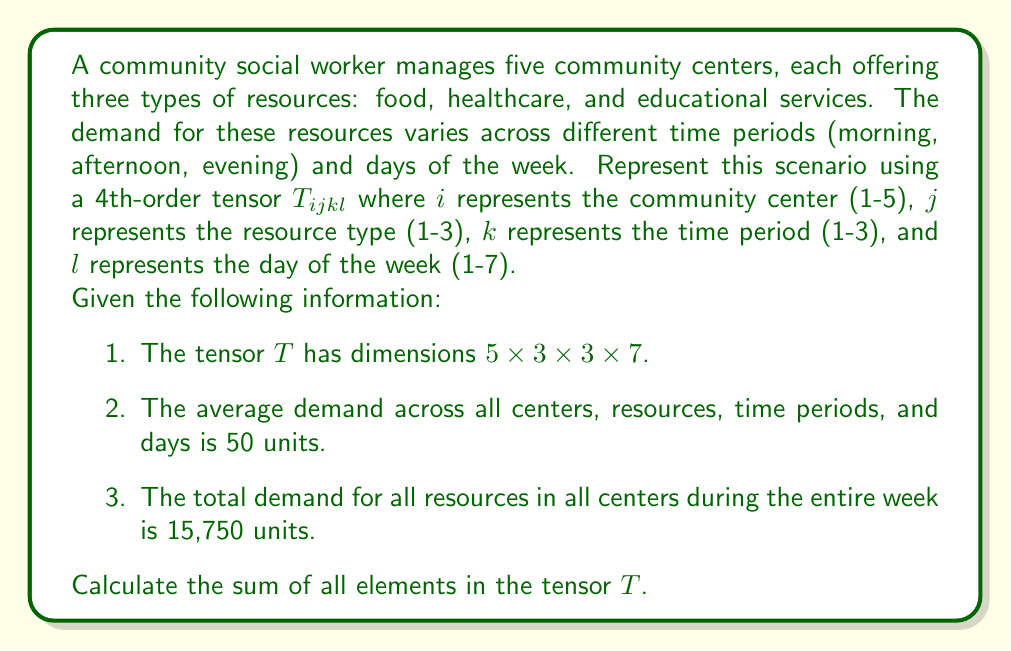Could you help me with this problem? To solve this problem, we'll follow these steps:

1) First, let's understand what the tensor $T_{ijkl}$ represents:
   - $i$ ranges from 1 to 5 (community centers)
   - $j$ ranges from 1 to 3 (resource types)
   - $k$ ranges from 1 to 3 (time periods)
   - $l$ ranges from 1 to 7 (days of the week)

2) The total number of elements in the tensor is:
   $$ 5 \times 3 \times 3 \times 7 = 315 $$

3) We're given that the average demand across all elements is 50 units. In tensor notation, this can be expressed as:

   $$ \frac{1}{315} \sum_{i=1}^5 \sum_{j=1}^3 \sum_{k=1}^3 \sum_{l=1}^7 T_{ijkl} = 50 $$

4) To find the sum of all elements, we need to multiply both sides by 315:

   $$ \sum_{i=1}^5 \sum_{j=1}^3 \sum_{k=1}^3 \sum_{l=1}^7 T_{ijkl} = 50 \times 315 = 15,750 $$

5) This result matches the given information that the total demand for all resources in all centers during the entire week is 15,750 units.

Therefore, the sum of all elements in the tensor $T$ is 15,750.
Answer: 15,750 